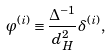Convert formula to latex. <formula><loc_0><loc_0><loc_500><loc_500>\varphi ^ { ( i ) } \equiv \frac { \Delta ^ { - 1 } } { d _ { H } ^ { 2 } } \delta ^ { ( i ) } ,</formula> 